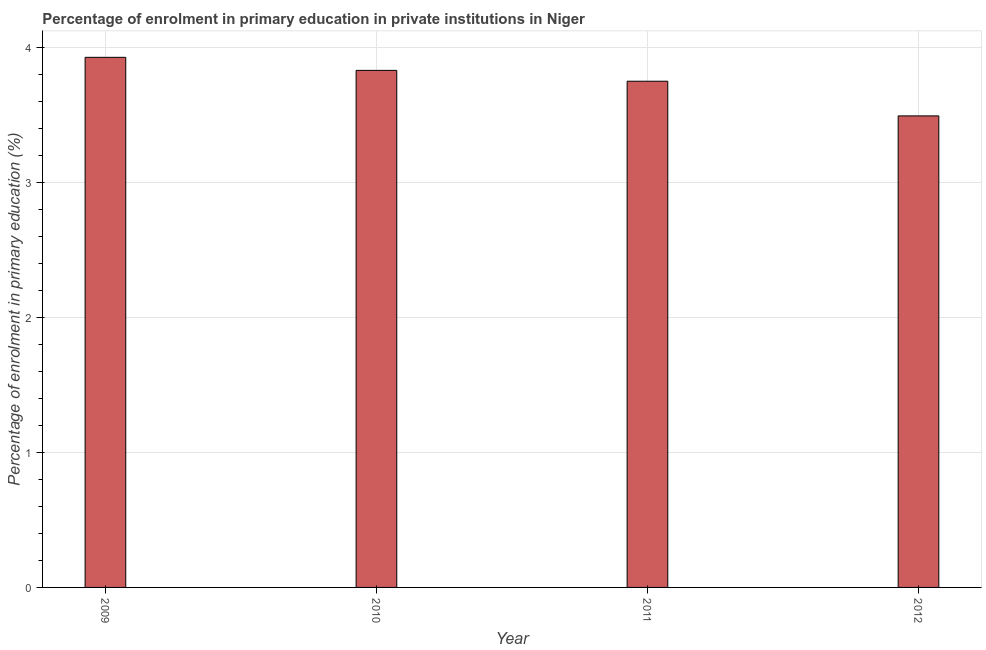Does the graph contain any zero values?
Offer a terse response. No. Does the graph contain grids?
Ensure brevity in your answer.  Yes. What is the title of the graph?
Ensure brevity in your answer.  Percentage of enrolment in primary education in private institutions in Niger. What is the label or title of the Y-axis?
Ensure brevity in your answer.  Percentage of enrolment in primary education (%). What is the enrolment percentage in primary education in 2011?
Your answer should be compact. 3.75. Across all years, what is the maximum enrolment percentage in primary education?
Ensure brevity in your answer.  3.93. Across all years, what is the minimum enrolment percentage in primary education?
Your answer should be compact. 3.49. In which year was the enrolment percentage in primary education maximum?
Make the answer very short. 2009. In which year was the enrolment percentage in primary education minimum?
Provide a succinct answer. 2012. What is the sum of the enrolment percentage in primary education?
Offer a very short reply. 15. What is the difference between the enrolment percentage in primary education in 2010 and 2012?
Keep it short and to the point. 0.34. What is the average enrolment percentage in primary education per year?
Your answer should be compact. 3.75. What is the median enrolment percentage in primary education?
Offer a very short reply. 3.79. What is the ratio of the enrolment percentage in primary education in 2011 to that in 2012?
Offer a very short reply. 1.07. What is the difference between the highest and the second highest enrolment percentage in primary education?
Provide a short and direct response. 0.1. What is the difference between the highest and the lowest enrolment percentage in primary education?
Make the answer very short. 0.43. In how many years, is the enrolment percentage in primary education greater than the average enrolment percentage in primary education taken over all years?
Your answer should be very brief. 2. Are all the bars in the graph horizontal?
Ensure brevity in your answer.  No. How many years are there in the graph?
Offer a terse response. 4. What is the difference between two consecutive major ticks on the Y-axis?
Make the answer very short. 1. What is the Percentage of enrolment in primary education (%) of 2009?
Give a very brief answer. 3.93. What is the Percentage of enrolment in primary education (%) of 2010?
Make the answer very short. 3.83. What is the Percentage of enrolment in primary education (%) of 2011?
Offer a very short reply. 3.75. What is the Percentage of enrolment in primary education (%) in 2012?
Offer a terse response. 3.49. What is the difference between the Percentage of enrolment in primary education (%) in 2009 and 2010?
Ensure brevity in your answer.  0.1. What is the difference between the Percentage of enrolment in primary education (%) in 2009 and 2011?
Your answer should be very brief. 0.18. What is the difference between the Percentage of enrolment in primary education (%) in 2009 and 2012?
Your answer should be compact. 0.43. What is the difference between the Percentage of enrolment in primary education (%) in 2010 and 2011?
Offer a very short reply. 0.08. What is the difference between the Percentage of enrolment in primary education (%) in 2010 and 2012?
Give a very brief answer. 0.34. What is the difference between the Percentage of enrolment in primary education (%) in 2011 and 2012?
Offer a very short reply. 0.26. What is the ratio of the Percentage of enrolment in primary education (%) in 2009 to that in 2011?
Make the answer very short. 1.05. What is the ratio of the Percentage of enrolment in primary education (%) in 2009 to that in 2012?
Your answer should be very brief. 1.12. What is the ratio of the Percentage of enrolment in primary education (%) in 2010 to that in 2012?
Provide a short and direct response. 1.1. What is the ratio of the Percentage of enrolment in primary education (%) in 2011 to that in 2012?
Your answer should be very brief. 1.07. 